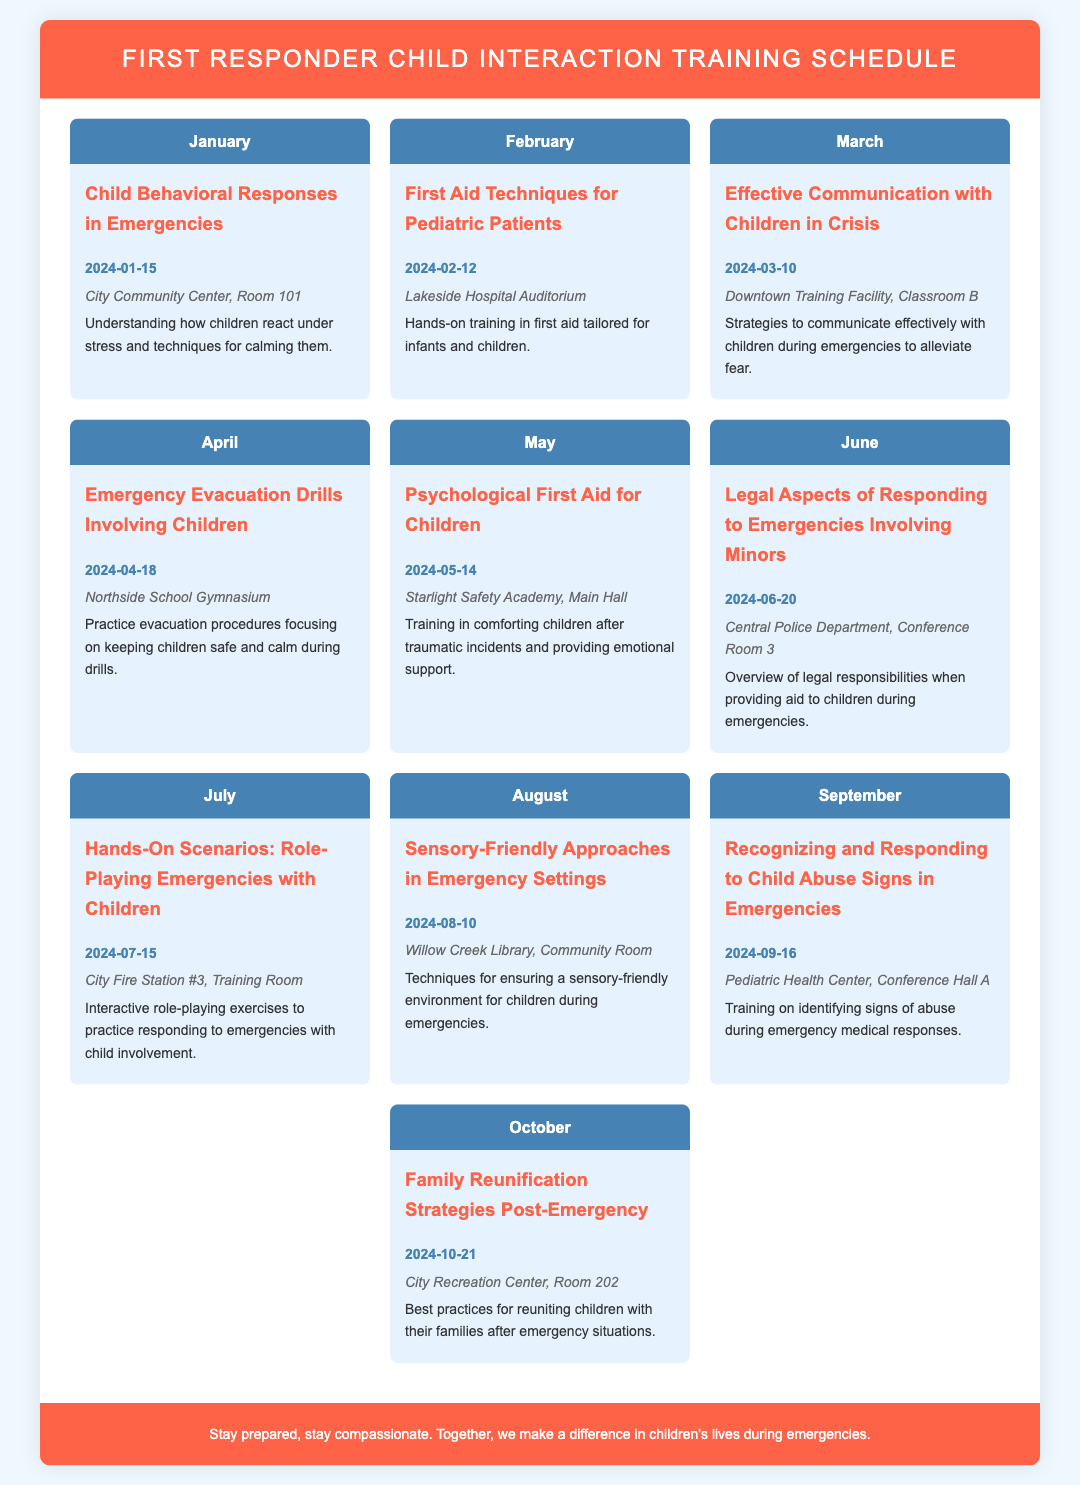What is the title of the document? The title of the document is clearly displayed at the top and states the main focus of the content.
Answer: First Responder Child Interaction Training Schedule When is the workshop on "Emergency Evacuation Drills Involving Children" scheduled? The date for this workshop can be found in the month of April within the document.
Answer: 2024-04-18 What location is the "Psychological First Aid for Children" workshop taking place? The specific venue for the workshop listed can be found within the month of May.
Answer: Starlight Safety Academy, Main Hall Which month features training on "Effective Communication with Children in Crisis"? The content outlines each month's focus, easily leading to the answer regarding the timing.
Answer: March Name one technique discussed in the "Sensory-Friendly Approaches in Emergency Settings" workshop. The workshop details techniques, highlighting one area of focus mentioned in the description.
Answer: Techniques for ensuring a sensory-friendly environment How many workshops are focused on training related to emergencies in the document? The number of workshops is based on counting each month's offering, which is presented straightforwardly in the document.
Answer: 10 What is the main goal of the training sessions mentioned in the document? The primary goal can be inferred from the context of the workshops and their descriptions.
Answer: Child interaction in emergencies Which month includes a workshop about recognizing signs of child abuse? The relevant month is clearly indicated within the document structure dedicated to each workshop.
Answer: September 